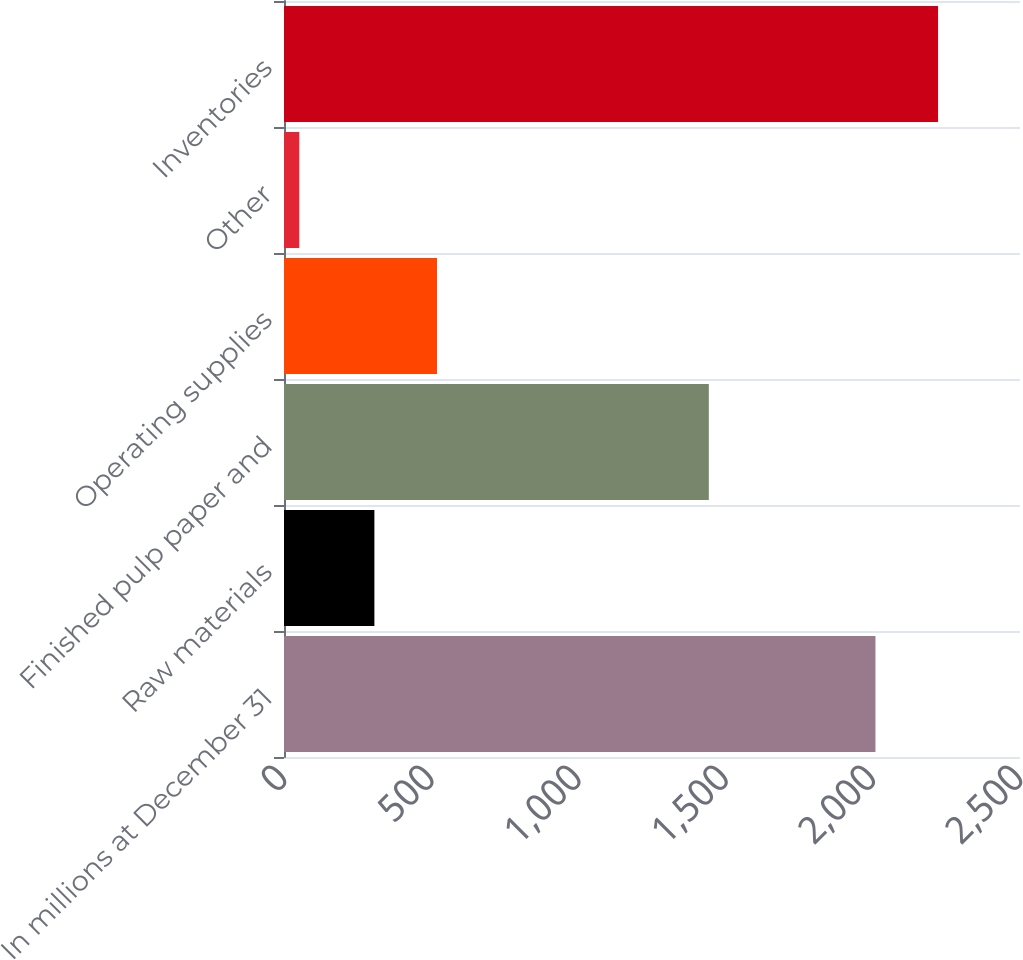Convert chart. <chart><loc_0><loc_0><loc_500><loc_500><bar_chart><fcel>In millions at December 31<fcel>Raw materials<fcel>Finished pulp paper and<fcel>Operating supplies<fcel>Other<fcel>Inventories<nl><fcel>2009<fcel>307<fcel>1443<fcel>519.7<fcel>52<fcel>2221.7<nl></chart> 